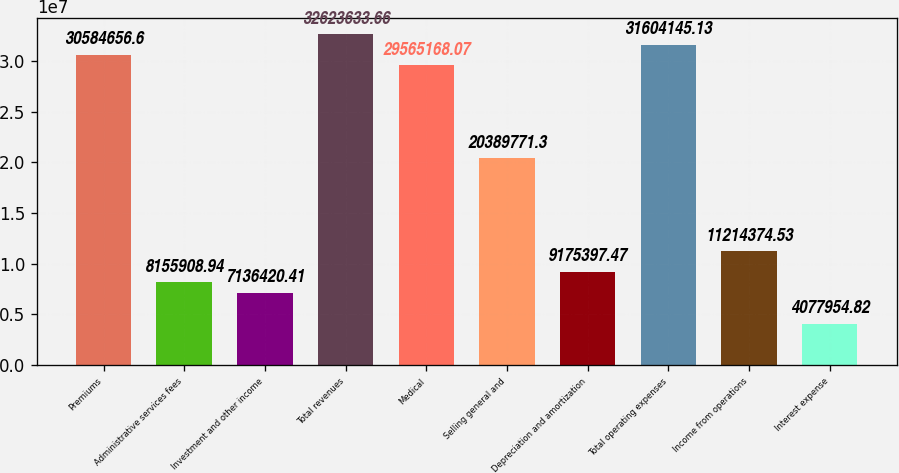Convert chart. <chart><loc_0><loc_0><loc_500><loc_500><bar_chart><fcel>Premiums<fcel>Administrative services fees<fcel>Investment and other income<fcel>Total revenues<fcel>Medical<fcel>Selling general and<fcel>Depreciation and amortization<fcel>Total operating expenses<fcel>Income from operations<fcel>Interest expense<nl><fcel>3.05847e+07<fcel>8.15591e+06<fcel>7.13642e+06<fcel>3.26236e+07<fcel>2.95652e+07<fcel>2.03898e+07<fcel>9.1754e+06<fcel>3.16041e+07<fcel>1.12144e+07<fcel>4.07795e+06<nl></chart> 